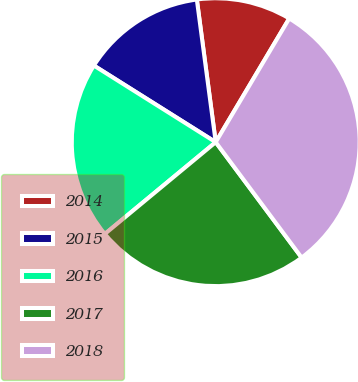<chart> <loc_0><loc_0><loc_500><loc_500><pie_chart><fcel>2014<fcel>2015<fcel>2016<fcel>2017<fcel>2018<nl><fcel>10.63%<fcel>13.97%<fcel>19.94%<fcel>24.18%<fcel>31.28%<nl></chart> 